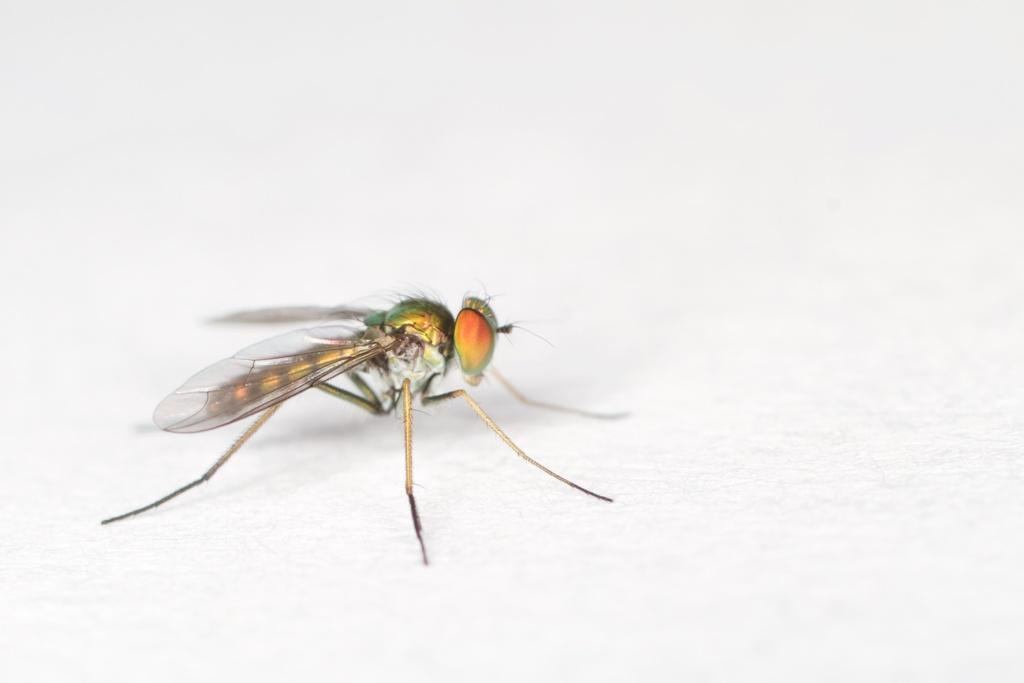What is the main subject of the image? There is a fly in the image. What color is the background of the image? The background of the image is white. What type of chalk is the fly using to draw on the wall in the image? There is no chalk or wall present in the image; it only features a fly. Is the fly wearing a scarf in the image? There is no scarf or any other clothing item visible on the fly in the image. 